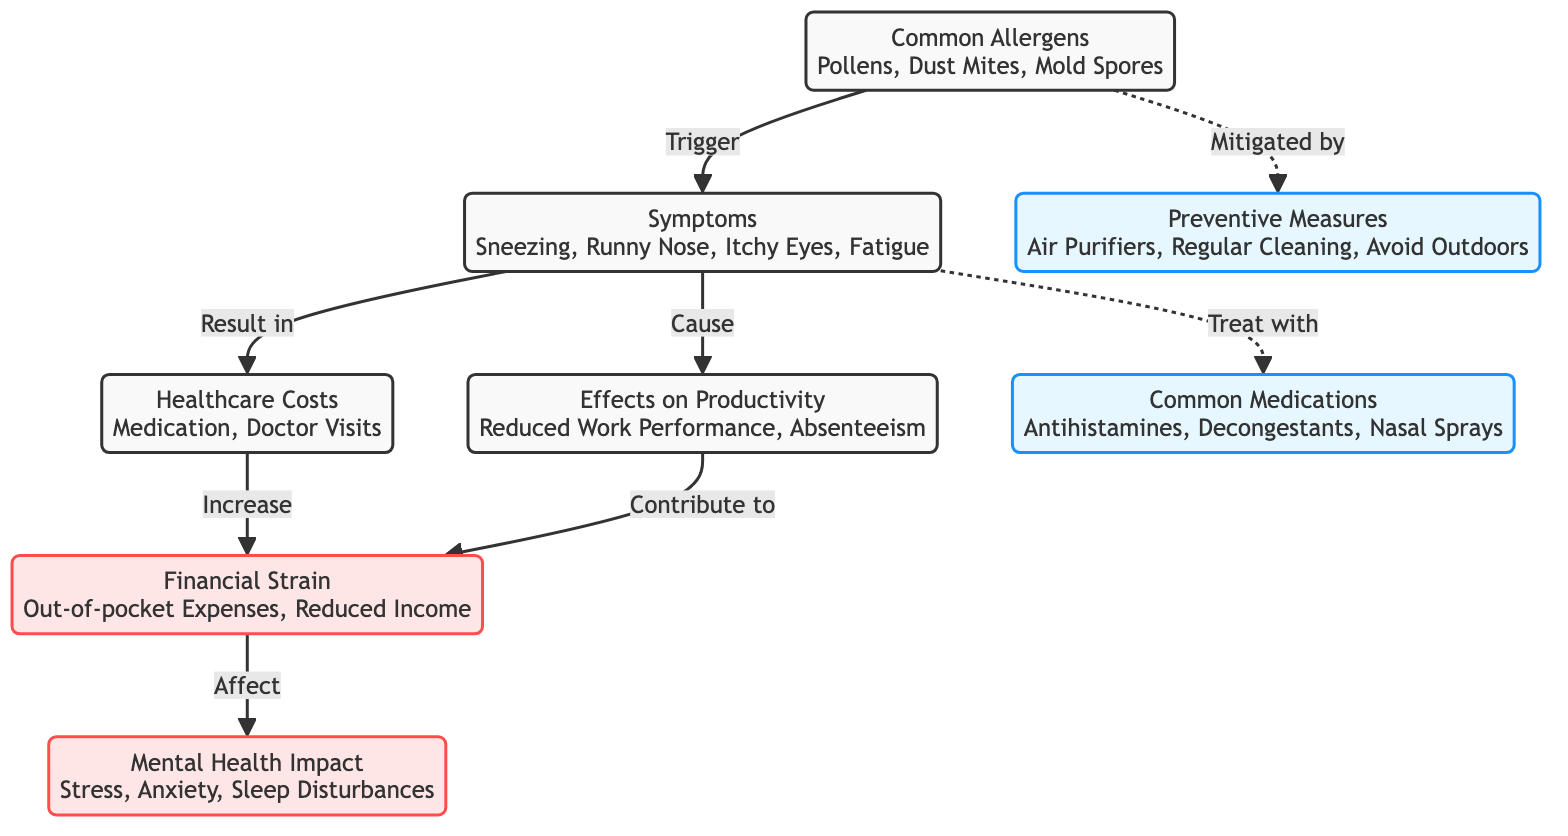What are common allergens? The diagram lists common allergens as Pollens, Dust Mites, and Mold Spores. This information is given directly as the title of the allergen node.
Answer: Pollens, Dust Mites, Mold Spores What symptoms are caused by allergens? From the diagram, symptoms that result from allergens include Sneezing, Runny Nose, Itchy Eyes, and Fatigue. This is directly indicated in the symptoms node.
Answer: Sneezing, Runny Nose, Itchy Eyes, Fatigue How do symptoms affect productivity? According to the diagram, symptoms cause Effects on Productivity, leading to Reduced Work Performance and Absenteeism, which is stated in the connecting edge.
Answer: Reduced Work Performance, Absenteeism What increases financial strain? The financial strain increases due to Healthcare Costs and Effects on Productivity as shown in the respective nodes and the associated arrows indicating the relationship.
Answer: Healthcare Costs, Effects on Productivity What preventive measures are suggested for allergens? The diagram indicates preventive measures as Air Purifiers, Regular Cleaning, and Avoid Outdoors. This information is provided in the preventive measures node.
Answer: Air Purifiers, Regular Cleaning, Avoid Outdoors How does financial strain affect mental health? From the diagram, financial strain affects mental health by contributing to Stress, Anxiety, and Sleep Disturbances. This is represented as a direct link between financial strain and mental health nodes.
Answer: Stress, Anxiety, Sleep Disturbances What type of medications can treat symptoms? The diagram includes Common Medications such as Antihistamines, Decongestants, and Nasal Sprays, which are explicitly mentioned in the medications node.
Answer: Antihistamines, Decongestants, Nasal Sprays What is the relationship between healthcare costs and financial strain? Healthcare costs increase financial strain, and this is directly shown by the relationship arrow in the diagram. Thus, healthcare costs have a direct impact on financial strain.
Answer: Increase How do allergens relate to preventive measures? Allergens can be mitigated by preventive measures, which is indicated by the dashed line in the diagram connecting these two nodes, signifying a relationship.
Answer: Mitigated by How are symptoms treated according to the diagram? Symptoms are treated with medications, which connect the symptoms node to the medications node, explicitly denoted in the diagram.
Answer: Treat with 